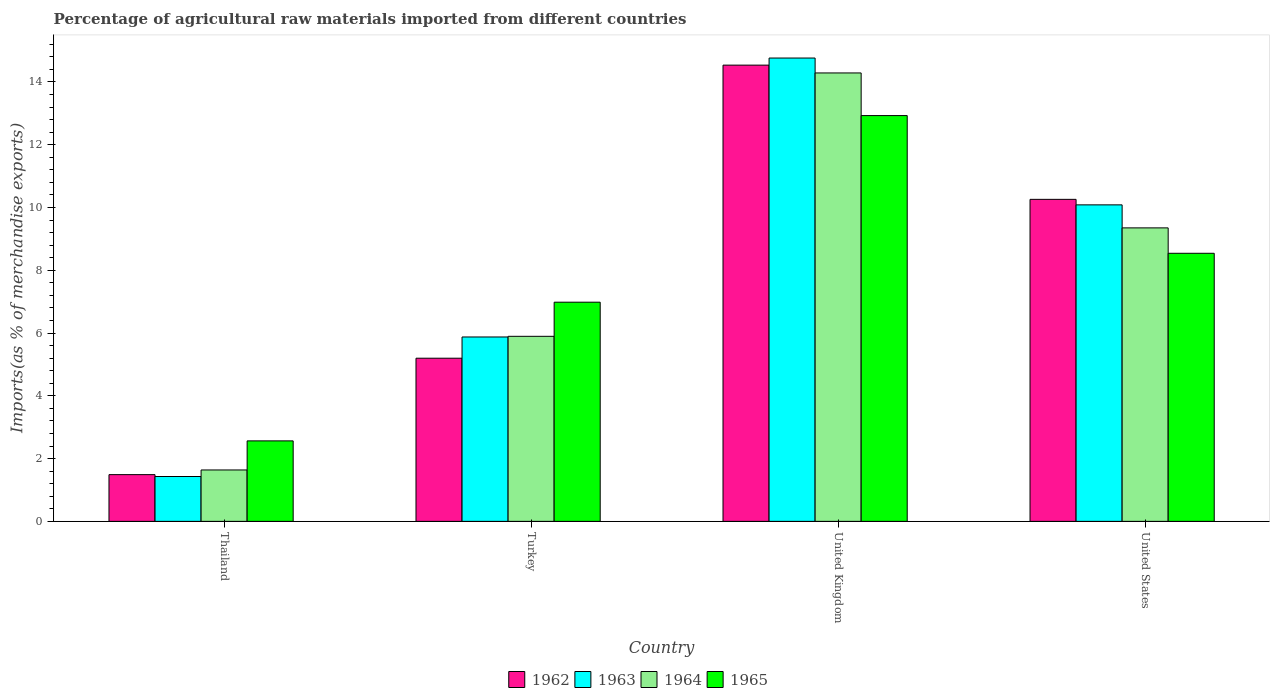How many groups of bars are there?
Offer a terse response. 4. Are the number of bars on each tick of the X-axis equal?
Offer a terse response. Yes. How many bars are there on the 2nd tick from the left?
Ensure brevity in your answer.  4. How many bars are there on the 2nd tick from the right?
Your response must be concise. 4. What is the label of the 2nd group of bars from the left?
Keep it short and to the point. Turkey. In how many cases, is the number of bars for a given country not equal to the number of legend labels?
Your response must be concise. 0. What is the percentage of imports to different countries in 1965 in United Kingdom?
Offer a terse response. 12.93. Across all countries, what is the maximum percentage of imports to different countries in 1965?
Provide a succinct answer. 12.93. Across all countries, what is the minimum percentage of imports to different countries in 1964?
Make the answer very short. 1.64. In which country was the percentage of imports to different countries in 1965 maximum?
Offer a terse response. United Kingdom. In which country was the percentage of imports to different countries in 1965 minimum?
Offer a terse response. Thailand. What is the total percentage of imports to different countries in 1965 in the graph?
Keep it short and to the point. 31.02. What is the difference between the percentage of imports to different countries in 1963 in Thailand and that in United Kingdom?
Offer a very short reply. -13.33. What is the difference between the percentage of imports to different countries in 1965 in Turkey and the percentage of imports to different countries in 1963 in United Kingdom?
Give a very brief answer. -7.78. What is the average percentage of imports to different countries in 1962 per country?
Offer a very short reply. 7.87. What is the difference between the percentage of imports to different countries of/in 1964 and percentage of imports to different countries of/in 1965 in United Kingdom?
Your answer should be compact. 1.36. In how many countries, is the percentage of imports to different countries in 1964 greater than 13.6 %?
Your answer should be compact. 1. What is the ratio of the percentage of imports to different countries in 1964 in United Kingdom to that in United States?
Make the answer very short. 1.53. Is the percentage of imports to different countries in 1964 in Turkey less than that in United Kingdom?
Ensure brevity in your answer.  Yes. Is the difference between the percentage of imports to different countries in 1964 in Thailand and United States greater than the difference between the percentage of imports to different countries in 1965 in Thailand and United States?
Offer a terse response. No. What is the difference between the highest and the second highest percentage of imports to different countries in 1965?
Provide a succinct answer. -4.39. What is the difference between the highest and the lowest percentage of imports to different countries in 1963?
Make the answer very short. 13.33. Is it the case that in every country, the sum of the percentage of imports to different countries in 1964 and percentage of imports to different countries in 1965 is greater than the sum of percentage of imports to different countries in 1963 and percentage of imports to different countries in 1962?
Provide a short and direct response. No. What does the 2nd bar from the left in United States represents?
Make the answer very short. 1963. What does the 1st bar from the right in United Kingdom represents?
Offer a very short reply. 1965. How many bars are there?
Keep it short and to the point. 16. Are all the bars in the graph horizontal?
Offer a very short reply. No. What is the difference between two consecutive major ticks on the Y-axis?
Offer a very short reply. 2. Does the graph contain any zero values?
Offer a very short reply. No. How are the legend labels stacked?
Your answer should be compact. Horizontal. What is the title of the graph?
Your answer should be very brief. Percentage of agricultural raw materials imported from different countries. What is the label or title of the X-axis?
Your response must be concise. Country. What is the label or title of the Y-axis?
Offer a very short reply. Imports(as % of merchandise exports). What is the Imports(as % of merchandise exports) of 1962 in Thailand?
Your response must be concise. 1.49. What is the Imports(as % of merchandise exports) of 1963 in Thailand?
Your answer should be very brief. 1.43. What is the Imports(as % of merchandise exports) in 1964 in Thailand?
Keep it short and to the point. 1.64. What is the Imports(as % of merchandise exports) in 1965 in Thailand?
Keep it short and to the point. 2.56. What is the Imports(as % of merchandise exports) of 1962 in Turkey?
Provide a succinct answer. 5.2. What is the Imports(as % of merchandise exports) of 1963 in Turkey?
Your answer should be very brief. 5.87. What is the Imports(as % of merchandise exports) in 1964 in Turkey?
Give a very brief answer. 5.9. What is the Imports(as % of merchandise exports) of 1965 in Turkey?
Make the answer very short. 6.98. What is the Imports(as % of merchandise exports) of 1962 in United Kingdom?
Offer a very short reply. 14.54. What is the Imports(as % of merchandise exports) in 1963 in United Kingdom?
Give a very brief answer. 14.76. What is the Imports(as % of merchandise exports) in 1964 in United Kingdom?
Ensure brevity in your answer.  14.29. What is the Imports(as % of merchandise exports) in 1965 in United Kingdom?
Keep it short and to the point. 12.93. What is the Imports(as % of merchandise exports) in 1962 in United States?
Give a very brief answer. 10.26. What is the Imports(as % of merchandise exports) of 1963 in United States?
Provide a short and direct response. 10.08. What is the Imports(as % of merchandise exports) of 1964 in United States?
Make the answer very short. 9.35. What is the Imports(as % of merchandise exports) in 1965 in United States?
Your answer should be very brief. 8.54. Across all countries, what is the maximum Imports(as % of merchandise exports) in 1962?
Offer a terse response. 14.54. Across all countries, what is the maximum Imports(as % of merchandise exports) of 1963?
Your answer should be very brief. 14.76. Across all countries, what is the maximum Imports(as % of merchandise exports) of 1964?
Provide a succinct answer. 14.29. Across all countries, what is the maximum Imports(as % of merchandise exports) in 1965?
Your response must be concise. 12.93. Across all countries, what is the minimum Imports(as % of merchandise exports) in 1962?
Offer a terse response. 1.49. Across all countries, what is the minimum Imports(as % of merchandise exports) in 1963?
Keep it short and to the point. 1.43. Across all countries, what is the minimum Imports(as % of merchandise exports) in 1964?
Offer a very short reply. 1.64. Across all countries, what is the minimum Imports(as % of merchandise exports) of 1965?
Provide a short and direct response. 2.56. What is the total Imports(as % of merchandise exports) of 1962 in the graph?
Keep it short and to the point. 31.48. What is the total Imports(as % of merchandise exports) of 1963 in the graph?
Provide a succinct answer. 32.15. What is the total Imports(as % of merchandise exports) of 1964 in the graph?
Your answer should be very brief. 31.17. What is the total Imports(as % of merchandise exports) in 1965 in the graph?
Keep it short and to the point. 31.02. What is the difference between the Imports(as % of merchandise exports) of 1962 in Thailand and that in Turkey?
Your answer should be very brief. -3.71. What is the difference between the Imports(as % of merchandise exports) of 1963 in Thailand and that in Turkey?
Your response must be concise. -4.45. What is the difference between the Imports(as % of merchandise exports) in 1964 in Thailand and that in Turkey?
Ensure brevity in your answer.  -4.26. What is the difference between the Imports(as % of merchandise exports) of 1965 in Thailand and that in Turkey?
Your response must be concise. -4.42. What is the difference between the Imports(as % of merchandise exports) in 1962 in Thailand and that in United Kingdom?
Offer a terse response. -13.05. What is the difference between the Imports(as % of merchandise exports) of 1963 in Thailand and that in United Kingdom?
Make the answer very short. -13.33. What is the difference between the Imports(as % of merchandise exports) in 1964 in Thailand and that in United Kingdom?
Ensure brevity in your answer.  -12.65. What is the difference between the Imports(as % of merchandise exports) in 1965 in Thailand and that in United Kingdom?
Your answer should be compact. -10.36. What is the difference between the Imports(as % of merchandise exports) in 1962 in Thailand and that in United States?
Provide a short and direct response. -8.77. What is the difference between the Imports(as % of merchandise exports) of 1963 in Thailand and that in United States?
Offer a terse response. -8.65. What is the difference between the Imports(as % of merchandise exports) in 1964 in Thailand and that in United States?
Ensure brevity in your answer.  -7.71. What is the difference between the Imports(as % of merchandise exports) in 1965 in Thailand and that in United States?
Make the answer very short. -5.98. What is the difference between the Imports(as % of merchandise exports) in 1962 in Turkey and that in United Kingdom?
Give a very brief answer. -9.34. What is the difference between the Imports(as % of merchandise exports) in 1963 in Turkey and that in United Kingdom?
Give a very brief answer. -8.89. What is the difference between the Imports(as % of merchandise exports) in 1964 in Turkey and that in United Kingdom?
Provide a short and direct response. -8.39. What is the difference between the Imports(as % of merchandise exports) of 1965 in Turkey and that in United Kingdom?
Keep it short and to the point. -5.95. What is the difference between the Imports(as % of merchandise exports) of 1962 in Turkey and that in United States?
Provide a short and direct response. -5.06. What is the difference between the Imports(as % of merchandise exports) of 1963 in Turkey and that in United States?
Keep it short and to the point. -4.21. What is the difference between the Imports(as % of merchandise exports) of 1964 in Turkey and that in United States?
Your response must be concise. -3.46. What is the difference between the Imports(as % of merchandise exports) in 1965 in Turkey and that in United States?
Make the answer very short. -1.56. What is the difference between the Imports(as % of merchandise exports) in 1962 in United Kingdom and that in United States?
Offer a very short reply. 4.28. What is the difference between the Imports(as % of merchandise exports) in 1963 in United Kingdom and that in United States?
Your answer should be very brief. 4.68. What is the difference between the Imports(as % of merchandise exports) in 1964 in United Kingdom and that in United States?
Ensure brevity in your answer.  4.94. What is the difference between the Imports(as % of merchandise exports) of 1965 in United Kingdom and that in United States?
Keep it short and to the point. 4.39. What is the difference between the Imports(as % of merchandise exports) of 1962 in Thailand and the Imports(as % of merchandise exports) of 1963 in Turkey?
Give a very brief answer. -4.39. What is the difference between the Imports(as % of merchandise exports) of 1962 in Thailand and the Imports(as % of merchandise exports) of 1964 in Turkey?
Make the answer very short. -4.41. What is the difference between the Imports(as % of merchandise exports) of 1962 in Thailand and the Imports(as % of merchandise exports) of 1965 in Turkey?
Provide a succinct answer. -5.49. What is the difference between the Imports(as % of merchandise exports) of 1963 in Thailand and the Imports(as % of merchandise exports) of 1964 in Turkey?
Provide a succinct answer. -4.47. What is the difference between the Imports(as % of merchandise exports) in 1963 in Thailand and the Imports(as % of merchandise exports) in 1965 in Turkey?
Offer a terse response. -5.55. What is the difference between the Imports(as % of merchandise exports) in 1964 in Thailand and the Imports(as % of merchandise exports) in 1965 in Turkey?
Provide a succinct answer. -5.35. What is the difference between the Imports(as % of merchandise exports) in 1962 in Thailand and the Imports(as % of merchandise exports) in 1963 in United Kingdom?
Your answer should be very brief. -13.27. What is the difference between the Imports(as % of merchandise exports) of 1962 in Thailand and the Imports(as % of merchandise exports) of 1964 in United Kingdom?
Offer a terse response. -12.8. What is the difference between the Imports(as % of merchandise exports) of 1962 in Thailand and the Imports(as % of merchandise exports) of 1965 in United Kingdom?
Offer a very short reply. -11.44. What is the difference between the Imports(as % of merchandise exports) in 1963 in Thailand and the Imports(as % of merchandise exports) in 1964 in United Kingdom?
Your answer should be very brief. -12.86. What is the difference between the Imports(as % of merchandise exports) in 1963 in Thailand and the Imports(as % of merchandise exports) in 1965 in United Kingdom?
Your answer should be compact. -11.5. What is the difference between the Imports(as % of merchandise exports) in 1964 in Thailand and the Imports(as % of merchandise exports) in 1965 in United Kingdom?
Offer a terse response. -11.29. What is the difference between the Imports(as % of merchandise exports) of 1962 in Thailand and the Imports(as % of merchandise exports) of 1963 in United States?
Give a very brief answer. -8.59. What is the difference between the Imports(as % of merchandise exports) in 1962 in Thailand and the Imports(as % of merchandise exports) in 1964 in United States?
Make the answer very short. -7.86. What is the difference between the Imports(as % of merchandise exports) in 1962 in Thailand and the Imports(as % of merchandise exports) in 1965 in United States?
Offer a terse response. -7.05. What is the difference between the Imports(as % of merchandise exports) in 1963 in Thailand and the Imports(as % of merchandise exports) in 1964 in United States?
Your answer should be compact. -7.92. What is the difference between the Imports(as % of merchandise exports) of 1963 in Thailand and the Imports(as % of merchandise exports) of 1965 in United States?
Offer a terse response. -7.11. What is the difference between the Imports(as % of merchandise exports) of 1964 in Thailand and the Imports(as % of merchandise exports) of 1965 in United States?
Give a very brief answer. -6.9. What is the difference between the Imports(as % of merchandise exports) of 1962 in Turkey and the Imports(as % of merchandise exports) of 1963 in United Kingdom?
Keep it short and to the point. -9.56. What is the difference between the Imports(as % of merchandise exports) in 1962 in Turkey and the Imports(as % of merchandise exports) in 1964 in United Kingdom?
Keep it short and to the point. -9.09. What is the difference between the Imports(as % of merchandise exports) of 1962 in Turkey and the Imports(as % of merchandise exports) of 1965 in United Kingdom?
Give a very brief answer. -7.73. What is the difference between the Imports(as % of merchandise exports) in 1963 in Turkey and the Imports(as % of merchandise exports) in 1964 in United Kingdom?
Your response must be concise. -8.41. What is the difference between the Imports(as % of merchandise exports) of 1963 in Turkey and the Imports(as % of merchandise exports) of 1965 in United Kingdom?
Offer a very short reply. -7.05. What is the difference between the Imports(as % of merchandise exports) of 1964 in Turkey and the Imports(as % of merchandise exports) of 1965 in United Kingdom?
Your answer should be very brief. -7.03. What is the difference between the Imports(as % of merchandise exports) in 1962 in Turkey and the Imports(as % of merchandise exports) in 1963 in United States?
Your answer should be very brief. -4.89. What is the difference between the Imports(as % of merchandise exports) in 1962 in Turkey and the Imports(as % of merchandise exports) in 1964 in United States?
Keep it short and to the point. -4.15. What is the difference between the Imports(as % of merchandise exports) in 1962 in Turkey and the Imports(as % of merchandise exports) in 1965 in United States?
Your answer should be very brief. -3.34. What is the difference between the Imports(as % of merchandise exports) in 1963 in Turkey and the Imports(as % of merchandise exports) in 1964 in United States?
Keep it short and to the point. -3.48. What is the difference between the Imports(as % of merchandise exports) of 1963 in Turkey and the Imports(as % of merchandise exports) of 1965 in United States?
Offer a very short reply. -2.67. What is the difference between the Imports(as % of merchandise exports) in 1964 in Turkey and the Imports(as % of merchandise exports) in 1965 in United States?
Provide a succinct answer. -2.65. What is the difference between the Imports(as % of merchandise exports) of 1962 in United Kingdom and the Imports(as % of merchandise exports) of 1963 in United States?
Offer a terse response. 4.45. What is the difference between the Imports(as % of merchandise exports) in 1962 in United Kingdom and the Imports(as % of merchandise exports) in 1964 in United States?
Give a very brief answer. 5.19. What is the difference between the Imports(as % of merchandise exports) of 1962 in United Kingdom and the Imports(as % of merchandise exports) of 1965 in United States?
Your answer should be compact. 5.99. What is the difference between the Imports(as % of merchandise exports) in 1963 in United Kingdom and the Imports(as % of merchandise exports) in 1964 in United States?
Give a very brief answer. 5.41. What is the difference between the Imports(as % of merchandise exports) in 1963 in United Kingdom and the Imports(as % of merchandise exports) in 1965 in United States?
Offer a terse response. 6.22. What is the difference between the Imports(as % of merchandise exports) of 1964 in United Kingdom and the Imports(as % of merchandise exports) of 1965 in United States?
Your response must be concise. 5.75. What is the average Imports(as % of merchandise exports) of 1962 per country?
Provide a short and direct response. 7.87. What is the average Imports(as % of merchandise exports) in 1963 per country?
Your response must be concise. 8.04. What is the average Imports(as % of merchandise exports) in 1964 per country?
Ensure brevity in your answer.  7.79. What is the average Imports(as % of merchandise exports) in 1965 per country?
Offer a terse response. 7.75. What is the difference between the Imports(as % of merchandise exports) in 1962 and Imports(as % of merchandise exports) in 1963 in Thailand?
Provide a short and direct response. 0.06. What is the difference between the Imports(as % of merchandise exports) in 1962 and Imports(as % of merchandise exports) in 1964 in Thailand?
Make the answer very short. -0.15. What is the difference between the Imports(as % of merchandise exports) in 1962 and Imports(as % of merchandise exports) in 1965 in Thailand?
Offer a terse response. -1.08. What is the difference between the Imports(as % of merchandise exports) in 1963 and Imports(as % of merchandise exports) in 1964 in Thailand?
Your answer should be compact. -0.21. What is the difference between the Imports(as % of merchandise exports) of 1963 and Imports(as % of merchandise exports) of 1965 in Thailand?
Your response must be concise. -1.13. What is the difference between the Imports(as % of merchandise exports) in 1964 and Imports(as % of merchandise exports) in 1965 in Thailand?
Your answer should be very brief. -0.93. What is the difference between the Imports(as % of merchandise exports) in 1962 and Imports(as % of merchandise exports) in 1963 in Turkey?
Provide a short and direct response. -0.68. What is the difference between the Imports(as % of merchandise exports) in 1962 and Imports(as % of merchandise exports) in 1964 in Turkey?
Offer a terse response. -0.7. What is the difference between the Imports(as % of merchandise exports) of 1962 and Imports(as % of merchandise exports) of 1965 in Turkey?
Your answer should be very brief. -1.78. What is the difference between the Imports(as % of merchandise exports) in 1963 and Imports(as % of merchandise exports) in 1964 in Turkey?
Your response must be concise. -0.02. What is the difference between the Imports(as % of merchandise exports) of 1963 and Imports(as % of merchandise exports) of 1965 in Turkey?
Ensure brevity in your answer.  -1.11. What is the difference between the Imports(as % of merchandise exports) of 1964 and Imports(as % of merchandise exports) of 1965 in Turkey?
Ensure brevity in your answer.  -1.09. What is the difference between the Imports(as % of merchandise exports) in 1962 and Imports(as % of merchandise exports) in 1963 in United Kingdom?
Keep it short and to the point. -0.23. What is the difference between the Imports(as % of merchandise exports) of 1962 and Imports(as % of merchandise exports) of 1964 in United Kingdom?
Provide a succinct answer. 0.25. What is the difference between the Imports(as % of merchandise exports) in 1962 and Imports(as % of merchandise exports) in 1965 in United Kingdom?
Provide a succinct answer. 1.61. What is the difference between the Imports(as % of merchandise exports) of 1963 and Imports(as % of merchandise exports) of 1964 in United Kingdom?
Provide a short and direct response. 0.47. What is the difference between the Imports(as % of merchandise exports) in 1963 and Imports(as % of merchandise exports) in 1965 in United Kingdom?
Offer a very short reply. 1.83. What is the difference between the Imports(as % of merchandise exports) of 1964 and Imports(as % of merchandise exports) of 1965 in United Kingdom?
Ensure brevity in your answer.  1.36. What is the difference between the Imports(as % of merchandise exports) of 1962 and Imports(as % of merchandise exports) of 1963 in United States?
Give a very brief answer. 0.18. What is the difference between the Imports(as % of merchandise exports) of 1962 and Imports(as % of merchandise exports) of 1965 in United States?
Your answer should be very brief. 1.72. What is the difference between the Imports(as % of merchandise exports) in 1963 and Imports(as % of merchandise exports) in 1964 in United States?
Provide a succinct answer. 0.73. What is the difference between the Imports(as % of merchandise exports) in 1963 and Imports(as % of merchandise exports) in 1965 in United States?
Provide a short and direct response. 1.54. What is the difference between the Imports(as % of merchandise exports) in 1964 and Imports(as % of merchandise exports) in 1965 in United States?
Provide a succinct answer. 0.81. What is the ratio of the Imports(as % of merchandise exports) in 1962 in Thailand to that in Turkey?
Provide a short and direct response. 0.29. What is the ratio of the Imports(as % of merchandise exports) in 1963 in Thailand to that in Turkey?
Give a very brief answer. 0.24. What is the ratio of the Imports(as % of merchandise exports) in 1964 in Thailand to that in Turkey?
Your answer should be very brief. 0.28. What is the ratio of the Imports(as % of merchandise exports) of 1965 in Thailand to that in Turkey?
Offer a terse response. 0.37. What is the ratio of the Imports(as % of merchandise exports) in 1962 in Thailand to that in United Kingdom?
Provide a short and direct response. 0.1. What is the ratio of the Imports(as % of merchandise exports) in 1963 in Thailand to that in United Kingdom?
Your response must be concise. 0.1. What is the ratio of the Imports(as % of merchandise exports) in 1964 in Thailand to that in United Kingdom?
Your answer should be compact. 0.11. What is the ratio of the Imports(as % of merchandise exports) in 1965 in Thailand to that in United Kingdom?
Provide a succinct answer. 0.2. What is the ratio of the Imports(as % of merchandise exports) in 1962 in Thailand to that in United States?
Ensure brevity in your answer.  0.15. What is the ratio of the Imports(as % of merchandise exports) of 1963 in Thailand to that in United States?
Offer a terse response. 0.14. What is the ratio of the Imports(as % of merchandise exports) of 1964 in Thailand to that in United States?
Make the answer very short. 0.18. What is the ratio of the Imports(as % of merchandise exports) in 1965 in Thailand to that in United States?
Provide a short and direct response. 0.3. What is the ratio of the Imports(as % of merchandise exports) in 1962 in Turkey to that in United Kingdom?
Ensure brevity in your answer.  0.36. What is the ratio of the Imports(as % of merchandise exports) in 1963 in Turkey to that in United Kingdom?
Offer a very short reply. 0.4. What is the ratio of the Imports(as % of merchandise exports) of 1964 in Turkey to that in United Kingdom?
Make the answer very short. 0.41. What is the ratio of the Imports(as % of merchandise exports) in 1965 in Turkey to that in United Kingdom?
Provide a succinct answer. 0.54. What is the ratio of the Imports(as % of merchandise exports) of 1962 in Turkey to that in United States?
Provide a succinct answer. 0.51. What is the ratio of the Imports(as % of merchandise exports) in 1963 in Turkey to that in United States?
Your answer should be very brief. 0.58. What is the ratio of the Imports(as % of merchandise exports) of 1964 in Turkey to that in United States?
Your answer should be compact. 0.63. What is the ratio of the Imports(as % of merchandise exports) of 1965 in Turkey to that in United States?
Keep it short and to the point. 0.82. What is the ratio of the Imports(as % of merchandise exports) of 1962 in United Kingdom to that in United States?
Provide a short and direct response. 1.42. What is the ratio of the Imports(as % of merchandise exports) in 1963 in United Kingdom to that in United States?
Offer a terse response. 1.46. What is the ratio of the Imports(as % of merchandise exports) in 1964 in United Kingdom to that in United States?
Provide a short and direct response. 1.53. What is the ratio of the Imports(as % of merchandise exports) of 1965 in United Kingdom to that in United States?
Provide a succinct answer. 1.51. What is the difference between the highest and the second highest Imports(as % of merchandise exports) in 1962?
Give a very brief answer. 4.28. What is the difference between the highest and the second highest Imports(as % of merchandise exports) in 1963?
Provide a succinct answer. 4.68. What is the difference between the highest and the second highest Imports(as % of merchandise exports) of 1964?
Your answer should be very brief. 4.94. What is the difference between the highest and the second highest Imports(as % of merchandise exports) in 1965?
Your response must be concise. 4.39. What is the difference between the highest and the lowest Imports(as % of merchandise exports) in 1962?
Provide a succinct answer. 13.05. What is the difference between the highest and the lowest Imports(as % of merchandise exports) in 1963?
Your answer should be very brief. 13.33. What is the difference between the highest and the lowest Imports(as % of merchandise exports) of 1964?
Make the answer very short. 12.65. What is the difference between the highest and the lowest Imports(as % of merchandise exports) in 1965?
Offer a terse response. 10.36. 